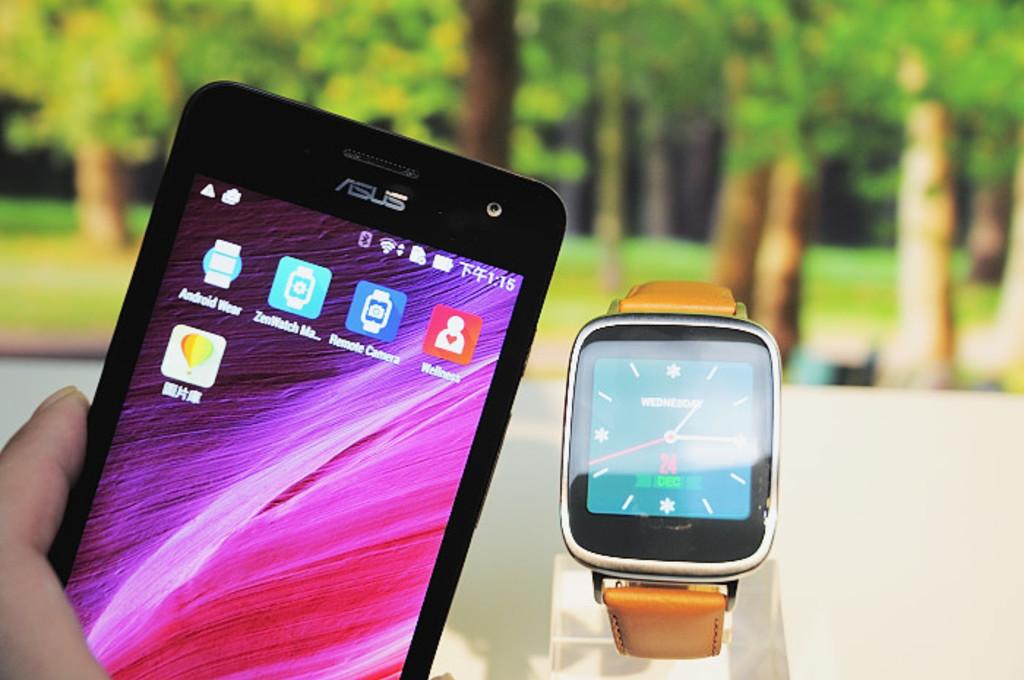What brand of phone is that?
Your response must be concise. Asus. What time is it?
Ensure brevity in your answer.  1:15. 